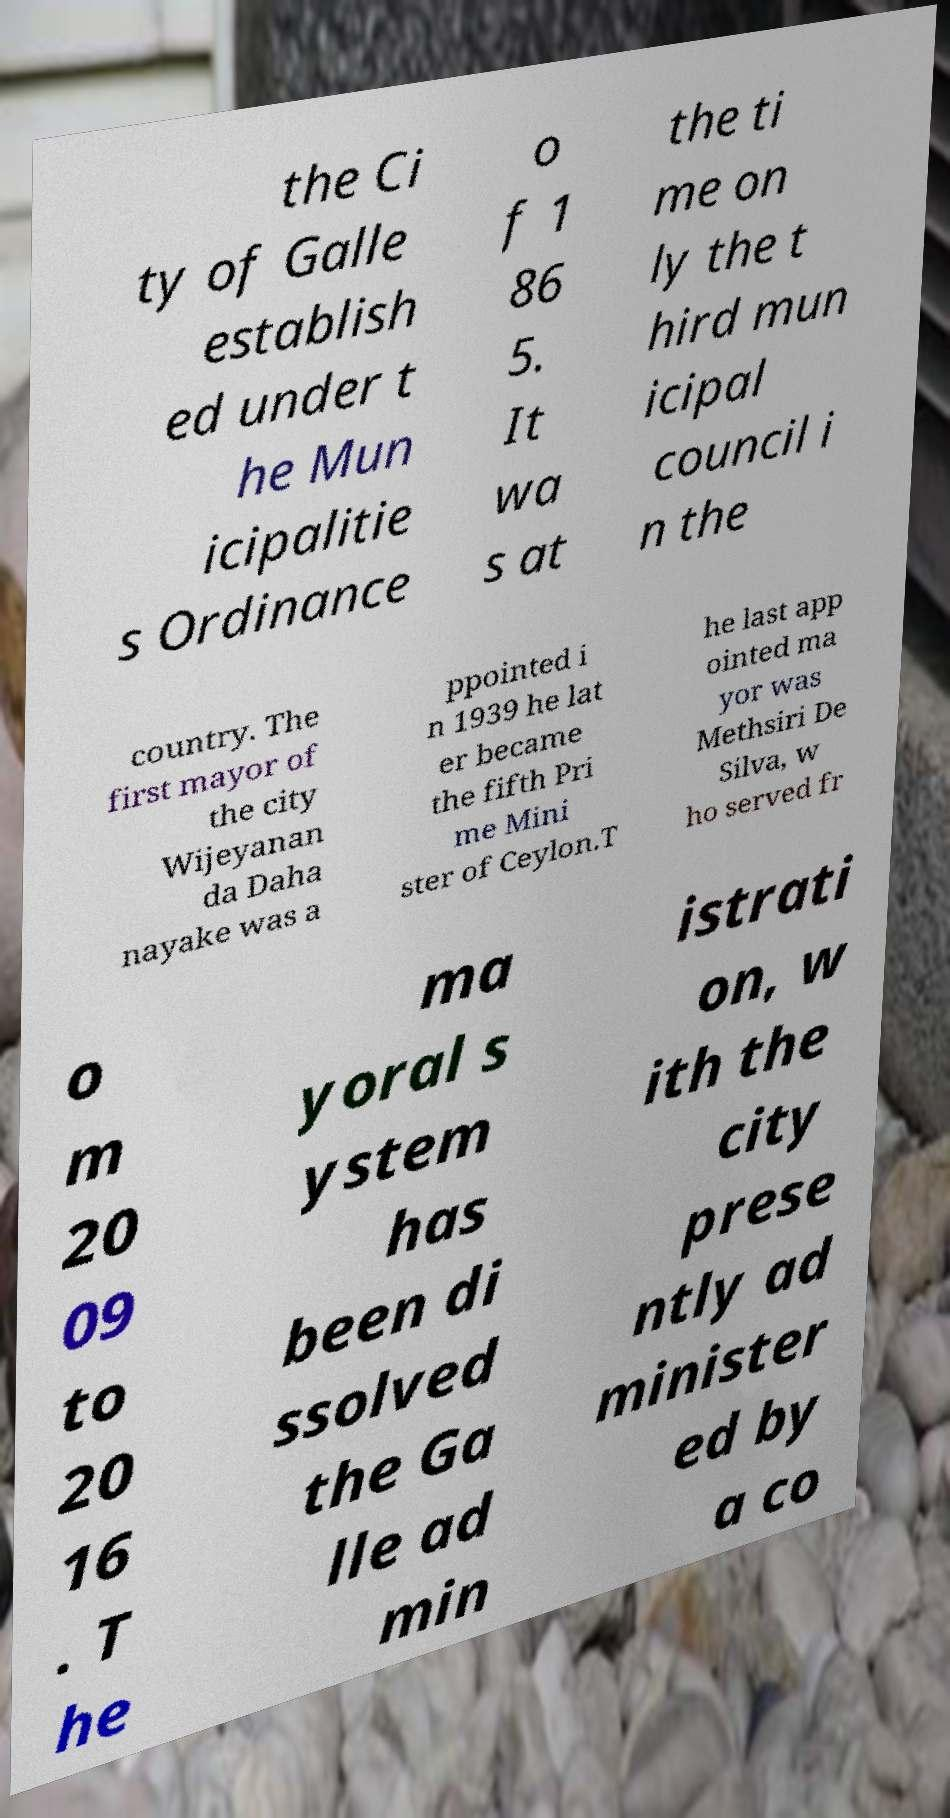Could you extract and type out the text from this image? the Ci ty of Galle establish ed under t he Mun icipalitie s Ordinance o f 1 86 5. It wa s at the ti me on ly the t hird mun icipal council i n the country. The first mayor of the city Wijeyanan da Daha nayake was a ppointed i n 1939 he lat er became the fifth Pri me Mini ster of Ceylon.T he last app ointed ma yor was Methsiri De Silva, w ho served fr o m 20 09 to 20 16 . T he ma yoral s ystem has been di ssolved the Ga lle ad min istrati on, w ith the city prese ntly ad minister ed by a co 